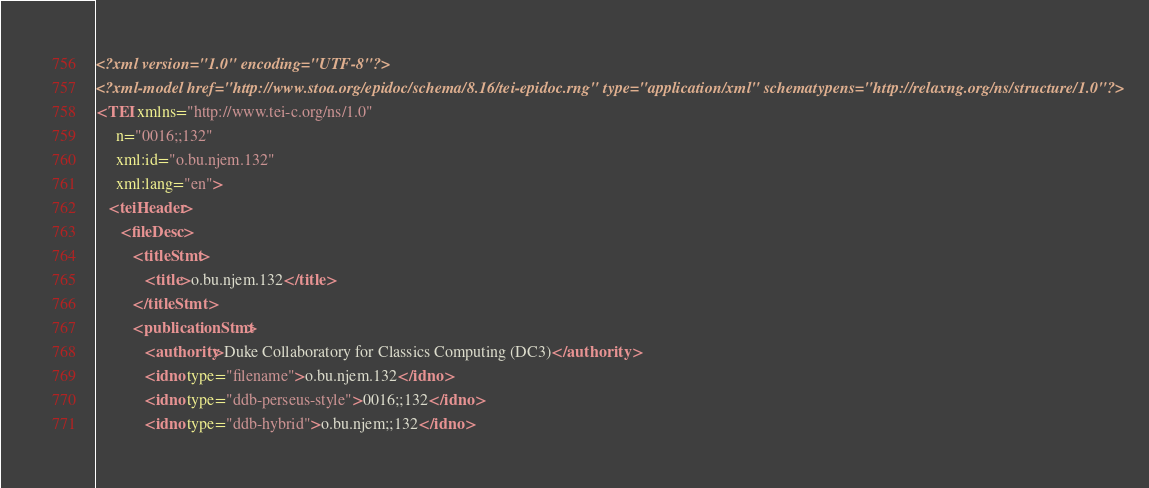<code> <loc_0><loc_0><loc_500><loc_500><_XML_><?xml version="1.0" encoding="UTF-8"?>
<?xml-model href="http://www.stoa.org/epidoc/schema/8.16/tei-epidoc.rng" type="application/xml" schematypens="http://relaxng.org/ns/structure/1.0"?>
<TEI xmlns="http://www.tei-c.org/ns/1.0"
     n="0016;;132"
     xml:id="o.bu.njem.132"
     xml:lang="en">
   <teiHeader>
      <fileDesc>
         <titleStmt>
            <title>o.bu.njem.132</title>
         </titleStmt>
         <publicationStmt>
            <authority>Duke Collaboratory for Classics Computing (DC3)</authority>
            <idno type="filename">o.bu.njem.132</idno>
            <idno type="ddb-perseus-style">0016;;132</idno>
            <idno type="ddb-hybrid">o.bu.njem;;132</idno></code> 